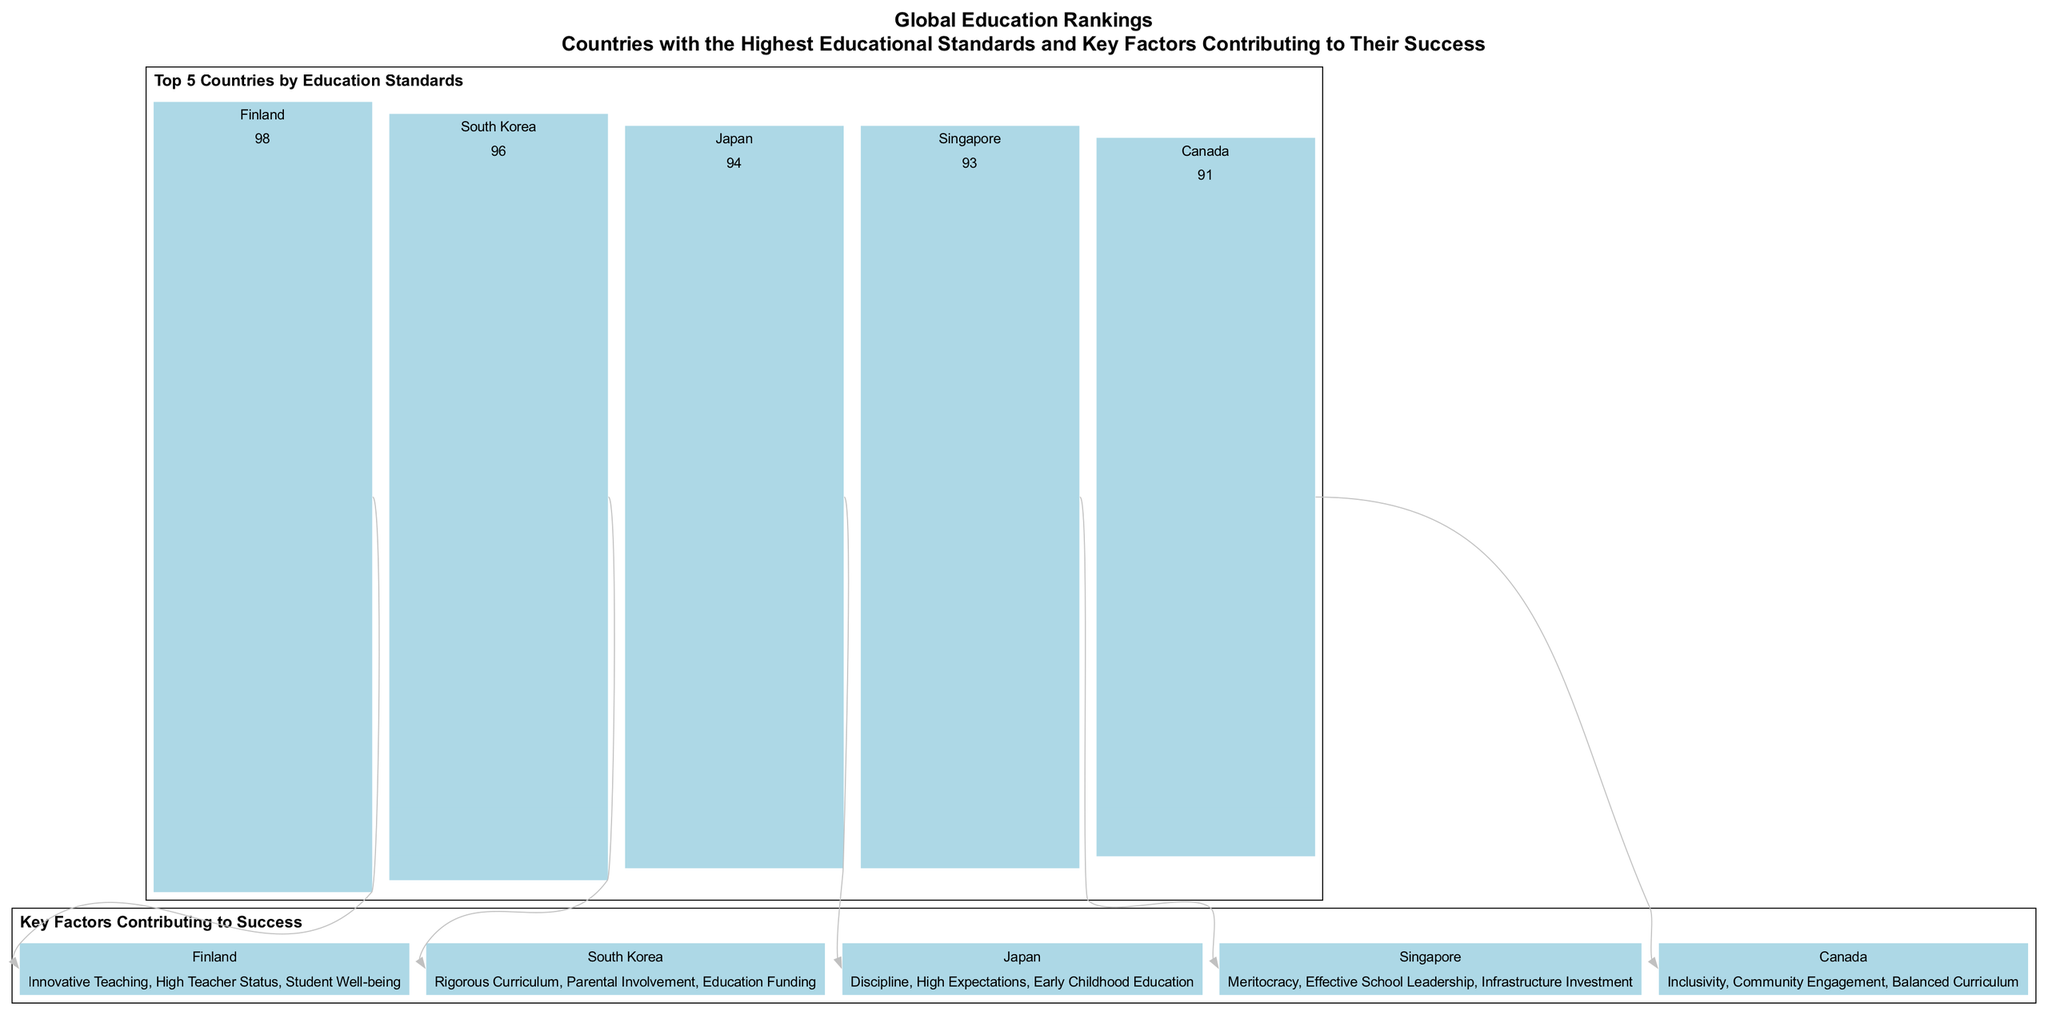What is the highest education score in the diagram? The bar chart displays the scores for each country, and Finland has the highest score of 98, which is evident from the height of its bar compared to the others.
Answer: 98 Which country ranks second in education score? The bar chart lists the scores, and the second-highest is South Korea with a score of 96, shown by the height of its bar relative to the others.
Answer: South Korea What are the key factors contributing to Finland's educational success? The table provides information on the key factors; for Finland, it lists "Innovative Teaching, High Teacher Status, Student Well-being," which can be directly read from the respective row in the table.
Answer: Innovative Teaching, High Teacher Status, Student Well-being How many countries are represented in the education rankings? The bar chart shows five distinct countries, which are listed on the x-axis, confirming there are exactly five countries represented in the rankings.
Answer: 5 Which country has a key factor of "Education Funding"? By referencing the key factors table, South Korea is specifically listed with "Education Funding" as a contributing factor, identifiable in the respective row for South Korea.
Answer: South Korea What factor contributes to Japan's educational success? The corresponding row for Japan in the key factors table describes multiple contributions, including "Discipline, High Expectations, Early Childhood Education," which are written together.
Answer: Discipline, High Expectations, Early Childhood Education Which country has a score closest to 90? Reviewing the scores, Canada has a score of 91, which is the closest value to 90 when compared to others in the bar chart.
Answer: Canada What is the common theme among the key factors for Singapore? The table suggests that Singapore emphasizes leadership and infrastructure, as seen from the "Effective School Leadership" and "Infrastructure Investment" listed under its key factors, indicating a common theme of governance and resources.
Answer: Meritocracy, Effective School Leadership, Infrastructure Investment How does the education score of Japan compare to that of Singapore? The scores indicate that Japan has a score of 94 while Singapore has 93, making Japan's score higher by 1 point, which can be directly compared from the bar heights.
Answer: Japan has a score of 94, Singapore a score of 93 